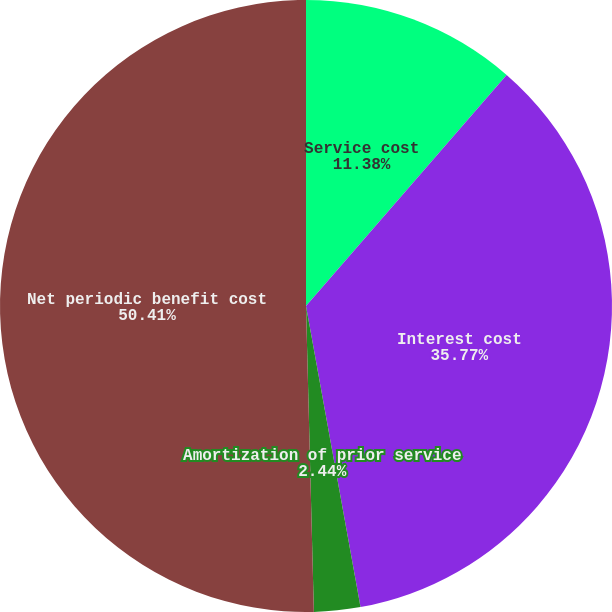Convert chart. <chart><loc_0><loc_0><loc_500><loc_500><pie_chart><fcel>Service cost<fcel>Interest cost<fcel>Amortization of prior service<fcel>Net periodic benefit cost<nl><fcel>11.38%<fcel>35.77%<fcel>2.44%<fcel>50.41%<nl></chart> 